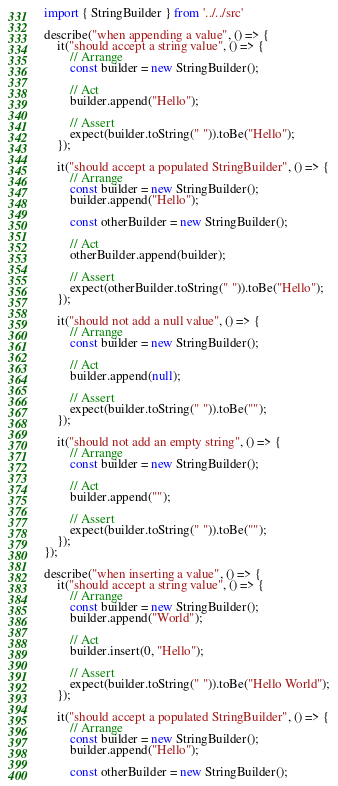Convert code to text. <code><loc_0><loc_0><loc_500><loc_500><_TypeScript_>import { StringBuilder } from '../../src'

describe("when appending a value", () => {
    it("should accept a string value", () => {
        // Arrange
        const builder = new StringBuilder();

        // Act
        builder.append("Hello");

        // Assert
        expect(builder.toString(" ")).toBe("Hello");
    });

    it("should accept a populated StringBuilder", () => {
        // Arrange
        const builder = new StringBuilder();
        builder.append("Hello");

        const otherBuilder = new StringBuilder();

        // Act
        otherBuilder.append(builder);

        // Assert
        expect(otherBuilder.toString(" ")).toBe("Hello");
    });

    it("should not add a null value", () => {
        // Arrange
        const builder = new StringBuilder();

        // Act
        builder.append(null);

        // Assert
        expect(builder.toString(" ")).toBe("");
    });

    it("should not add an empty string", () => {
        // Arrange
        const builder = new StringBuilder();

        // Act
        builder.append("");

        // Assert
        expect(builder.toString(" ")).toBe("");
    });
});

describe("when inserting a value", () => {
    it("should accept a string value", () => {
        // Arrange
        const builder = new StringBuilder();
        builder.append("World");

        // Act
        builder.insert(0, "Hello");

        // Assert
        expect(builder.toString(" ")).toBe("Hello World");
    });

    it("should accept a populated StringBuilder", () => {
        // Arrange
        const builder = new StringBuilder();
        builder.append("Hello");

        const otherBuilder = new StringBuilder();</code> 